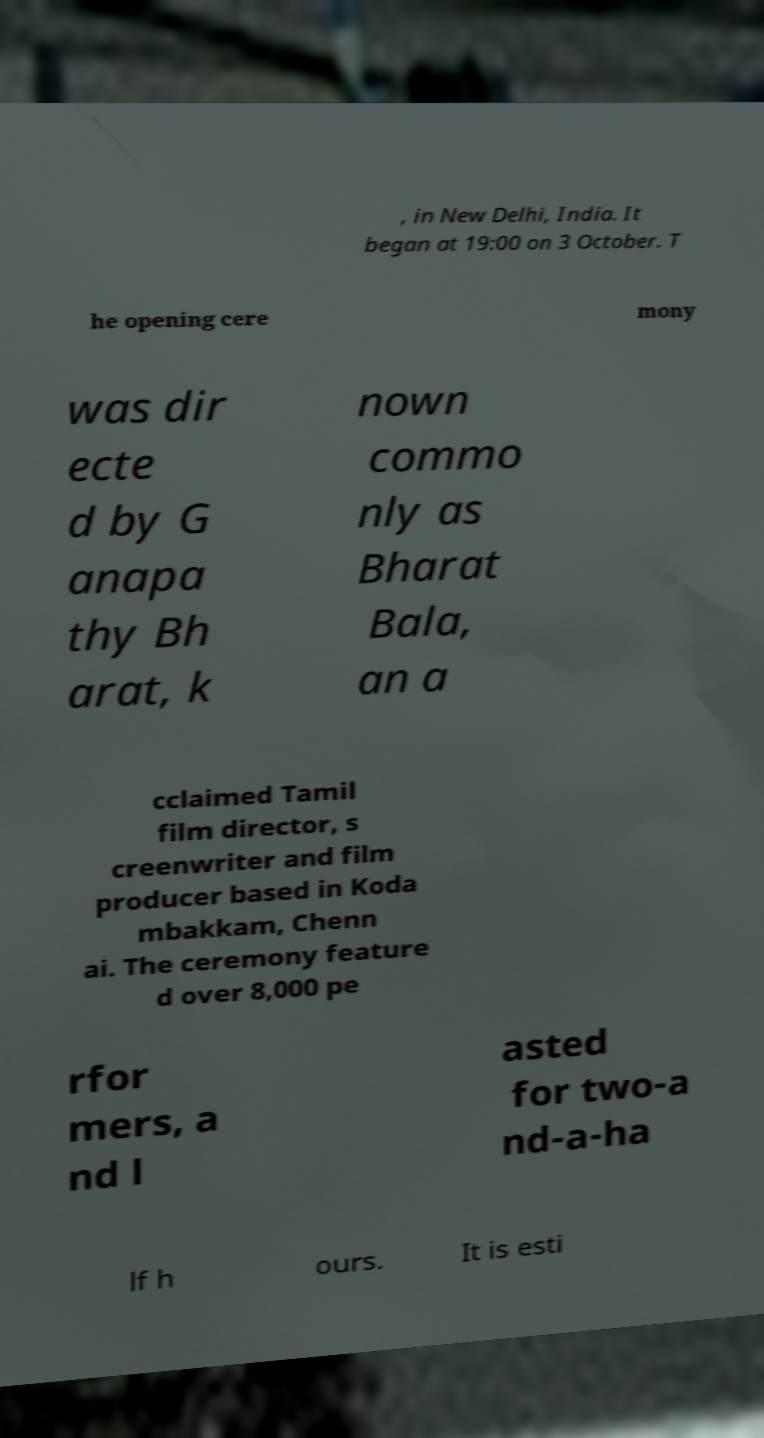I need the written content from this picture converted into text. Can you do that? , in New Delhi, India. It began at 19:00 on 3 October. T he opening cere mony was dir ecte d by G anapa thy Bh arat, k nown commo nly as Bharat Bala, an a cclaimed Tamil film director, s creenwriter and film producer based in Koda mbakkam, Chenn ai. The ceremony feature d over 8,000 pe rfor mers, a nd l asted for two-a nd-a-ha lf h ours. It is esti 